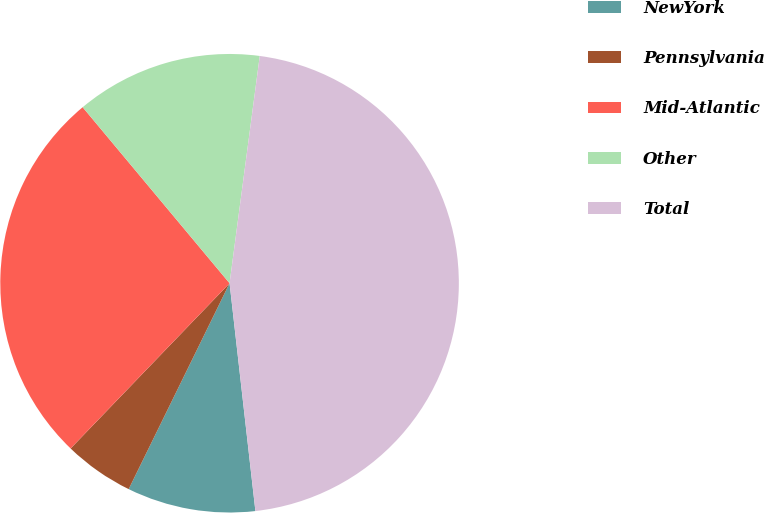<chart> <loc_0><loc_0><loc_500><loc_500><pie_chart><fcel>NewYork<fcel>Pennsylvania<fcel>Mid-Atlantic<fcel>Other<fcel>Total<nl><fcel>9.05%<fcel>4.94%<fcel>26.74%<fcel>13.17%<fcel>46.1%<nl></chart> 